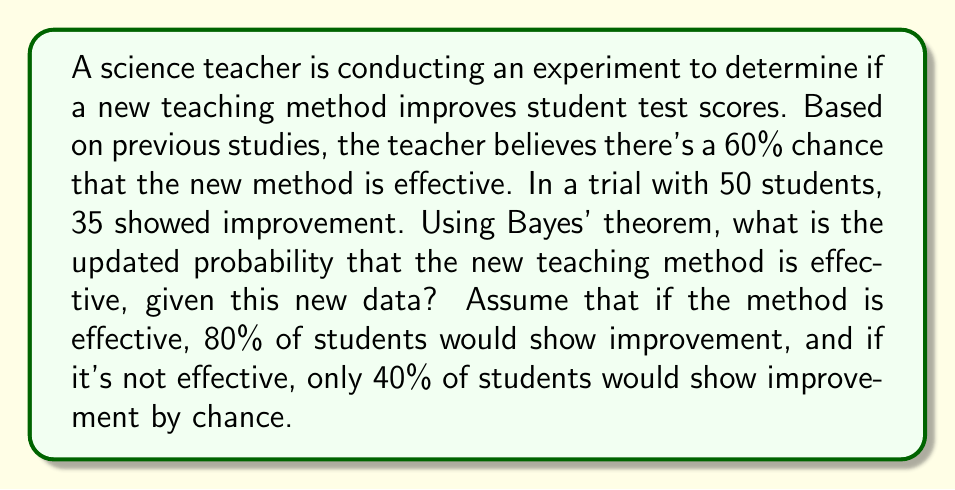Teach me how to tackle this problem. To solve this problem, we'll use Bayes' theorem:

$$P(A|B) = \frac{P(B|A) \cdot P(A)}{P(B)}$$

Where:
A = The new teaching method is effective
B = 35 out of 50 students showed improvement

Given:
- P(A) = 0.60 (prior probability)
- P(B|A) = P(35 out of 50 improve | method is effective) = $\binom{50}{35} \cdot 0.80^{35} \cdot 0.20^{15}$
- P(B|not A) = P(35 out of 50 improve | method is not effective) = $\binom{50}{35} \cdot 0.40^{35} \cdot 0.60^{15}$

Step 1: Calculate P(B|A) and P(B|not A)
Using the binomial probability formula:
P(B|A) = $\binom{50}{35} \cdot 0.80^{35} \cdot 0.20^{15} \approx 0.0888$
P(B|not A) = $\binom{50}{35} \cdot 0.40^{35} \cdot 0.60^{15} \approx 0.0002$

Step 2: Calculate P(B)
P(B) = P(B|A) · P(A) + P(B|not A) · P(not A)
     = 0.0888 · 0.60 + 0.0002 · 0.40
     ≈ 0.0533

Step 3: Apply Bayes' theorem
P(A|B) = $\frac{P(B|A) \cdot P(A)}{P(B)}$ = $\frac{0.0888 \cdot 0.60}{0.0533}$ ≈ 0.9988

Therefore, the updated probability that the new teaching method is effective, given the new data, is approximately 0.9988 or 99.88%.
Answer: The updated probability that the new teaching method is effective, given the new data, is approximately 0.9988 or 99.88%. 